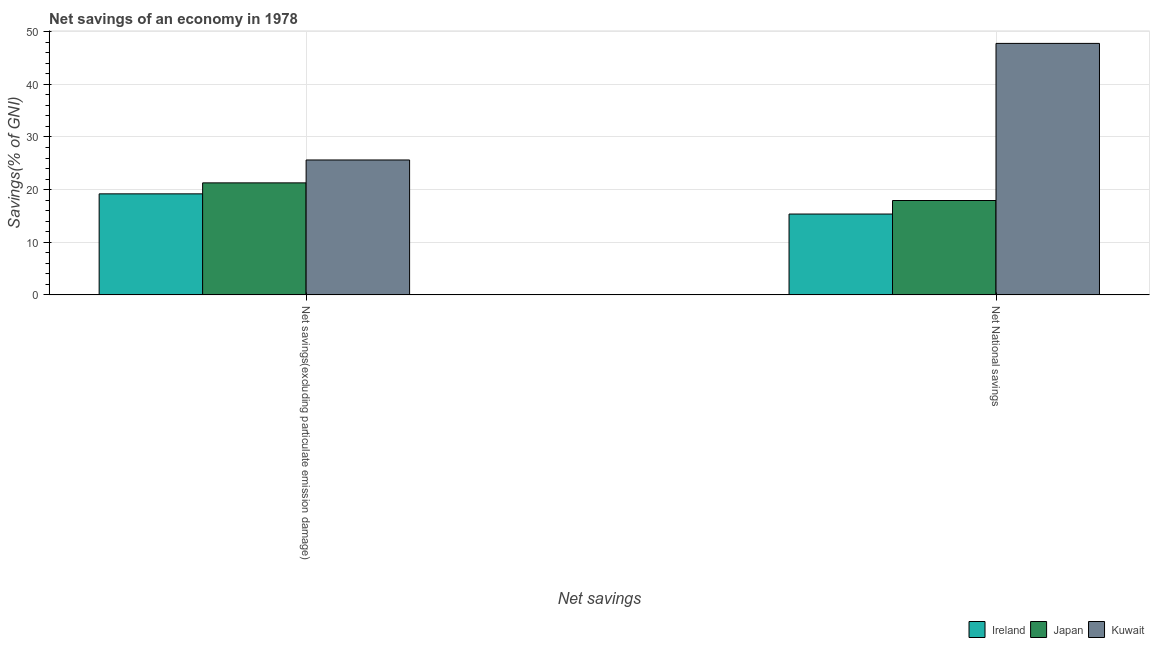How many different coloured bars are there?
Keep it short and to the point. 3. Are the number of bars on each tick of the X-axis equal?
Your answer should be very brief. Yes. How many bars are there on the 2nd tick from the left?
Give a very brief answer. 3. What is the label of the 1st group of bars from the left?
Your answer should be compact. Net savings(excluding particulate emission damage). What is the net savings(excluding particulate emission damage) in Ireland?
Offer a very short reply. 19.2. Across all countries, what is the maximum net national savings?
Provide a short and direct response. 47.78. Across all countries, what is the minimum net savings(excluding particulate emission damage)?
Your answer should be compact. 19.2. In which country was the net national savings maximum?
Provide a short and direct response. Kuwait. In which country was the net savings(excluding particulate emission damage) minimum?
Your answer should be very brief. Ireland. What is the total net savings(excluding particulate emission damage) in the graph?
Make the answer very short. 66.11. What is the difference between the net savings(excluding particulate emission damage) in Japan and that in Kuwait?
Keep it short and to the point. -4.35. What is the difference between the net savings(excluding particulate emission damage) in Japan and the net national savings in Kuwait?
Offer a very short reply. -26.5. What is the average net savings(excluding particulate emission damage) per country?
Ensure brevity in your answer.  22.04. What is the difference between the net savings(excluding particulate emission damage) and net national savings in Ireland?
Give a very brief answer. 3.83. What is the ratio of the net savings(excluding particulate emission damage) in Kuwait to that in Ireland?
Your response must be concise. 1.34. Is the net national savings in Japan less than that in Kuwait?
Give a very brief answer. Yes. In how many countries, is the net national savings greater than the average net national savings taken over all countries?
Your answer should be very brief. 1. What does the 3rd bar from the left in Net National savings represents?
Ensure brevity in your answer.  Kuwait. What does the 3rd bar from the right in Net National savings represents?
Provide a short and direct response. Ireland. Are all the bars in the graph horizontal?
Provide a short and direct response. No. How many legend labels are there?
Provide a succinct answer. 3. How are the legend labels stacked?
Give a very brief answer. Horizontal. What is the title of the graph?
Your answer should be compact. Net savings of an economy in 1978. Does "United Arab Emirates" appear as one of the legend labels in the graph?
Your response must be concise. No. What is the label or title of the X-axis?
Offer a very short reply. Net savings. What is the label or title of the Y-axis?
Make the answer very short. Savings(% of GNI). What is the Savings(% of GNI) of Ireland in Net savings(excluding particulate emission damage)?
Your answer should be compact. 19.2. What is the Savings(% of GNI) of Japan in Net savings(excluding particulate emission damage)?
Make the answer very short. 21.28. What is the Savings(% of GNI) in Kuwait in Net savings(excluding particulate emission damage)?
Offer a very short reply. 25.63. What is the Savings(% of GNI) in Ireland in Net National savings?
Give a very brief answer. 15.36. What is the Savings(% of GNI) in Japan in Net National savings?
Provide a short and direct response. 17.93. What is the Savings(% of GNI) of Kuwait in Net National savings?
Provide a short and direct response. 47.78. Across all Net savings, what is the maximum Savings(% of GNI) in Ireland?
Offer a terse response. 19.2. Across all Net savings, what is the maximum Savings(% of GNI) in Japan?
Offer a very short reply. 21.28. Across all Net savings, what is the maximum Savings(% of GNI) in Kuwait?
Offer a very short reply. 47.78. Across all Net savings, what is the minimum Savings(% of GNI) of Ireland?
Give a very brief answer. 15.36. Across all Net savings, what is the minimum Savings(% of GNI) in Japan?
Your answer should be compact. 17.93. Across all Net savings, what is the minimum Savings(% of GNI) of Kuwait?
Your response must be concise. 25.63. What is the total Savings(% of GNI) in Ireland in the graph?
Your response must be concise. 34.56. What is the total Savings(% of GNI) in Japan in the graph?
Give a very brief answer. 39.21. What is the total Savings(% of GNI) of Kuwait in the graph?
Keep it short and to the point. 73.41. What is the difference between the Savings(% of GNI) of Ireland in Net savings(excluding particulate emission damage) and that in Net National savings?
Your answer should be very brief. 3.83. What is the difference between the Savings(% of GNI) of Japan in Net savings(excluding particulate emission damage) and that in Net National savings?
Provide a succinct answer. 3.35. What is the difference between the Savings(% of GNI) of Kuwait in Net savings(excluding particulate emission damage) and that in Net National savings?
Your response must be concise. -22.15. What is the difference between the Savings(% of GNI) of Ireland in Net savings(excluding particulate emission damage) and the Savings(% of GNI) of Japan in Net National savings?
Offer a very short reply. 1.26. What is the difference between the Savings(% of GNI) in Ireland in Net savings(excluding particulate emission damage) and the Savings(% of GNI) in Kuwait in Net National savings?
Provide a succinct answer. -28.58. What is the difference between the Savings(% of GNI) in Japan in Net savings(excluding particulate emission damage) and the Savings(% of GNI) in Kuwait in Net National savings?
Your response must be concise. -26.5. What is the average Savings(% of GNI) of Ireland per Net savings?
Offer a terse response. 17.28. What is the average Savings(% of GNI) of Japan per Net savings?
Offer a very short reply. 19.61. What is the average Savings(% of GNI) of Kuwait per Net savings?
Provide a short and direct response. 36.7. What is the difference between the Savings(% of GNI) in Ireland and Savings(% of GNI) in Japan in Net savings(excluding particulate emission damage)?
Your response must be concise. -2.09. What is the difference between the Savings(% of GNI) in Ireland and Savings(% of GNI) in Kuwait in Net savings(excluding particulate emission damage)?
Offer a terse response. -6.43. What is the difference between the Savings(% of GNI) in Japan and Savings(% of GNI) in Kuwait in Net savings(excluding particulate emission damage)?
Your answer should be very brief. -4.35. What is the difference between the Savings(% of GNI) of Ireland and Savings(% of GNI) of Japan in Net National savings?
Offer a terse response. -2.57. What is the difference between the Savings(% of GNI) of Ireland and Savings(% of GNI) of Kuwait in Net National savings?
Offer a very short reply. -32.42. What is the difference between the Savings(% of GNI) in Japan and Savings(% of GNI) in Kuwait in Net National savings?
Your answer should be compact. -29.85. What is the ratio of the Savings(% of GNI) in Ireland in Net savings(excluding particulate emission damage) to that in Net National savings?
Provide a succinct answer. 1.25. What is the ratio of the Savings(% of GNI) of Japan in Net savings(excluding particulate emission damage) to that in Net National savings?
Offer a very short reply. 1.19. What is the ratio of the Savings(% of GNI) of Kuwait in Net savings(excluding particulate emission damage) to that in Net National savings?
Your response must be concise. 0.54. What is the difference between the highest and the second highest Savings(% of GNI) in Ireland?
Your answer should be compact. 3.83. What is the difference between the highest and the second highest Savings(% of GNI) in Japan?
Your response must be concise. 3.35. What is the difference between the highest and the second highest Savings(% of GNI) in Kuwait?
Your response must be concise. 22.15. What is the difference between the highest and the lowest Savings(% of GNI) in Ireland?
Your answer should be compact. 3.83. What is the difference between the highest and the lowest Savings(% of GNI) of Japan?
Your answer should be compact. 3.35. What is the difference between the highest and the lowest Savings(% of GNI) of Kuwait?
Make the answer very short. 22.15. 